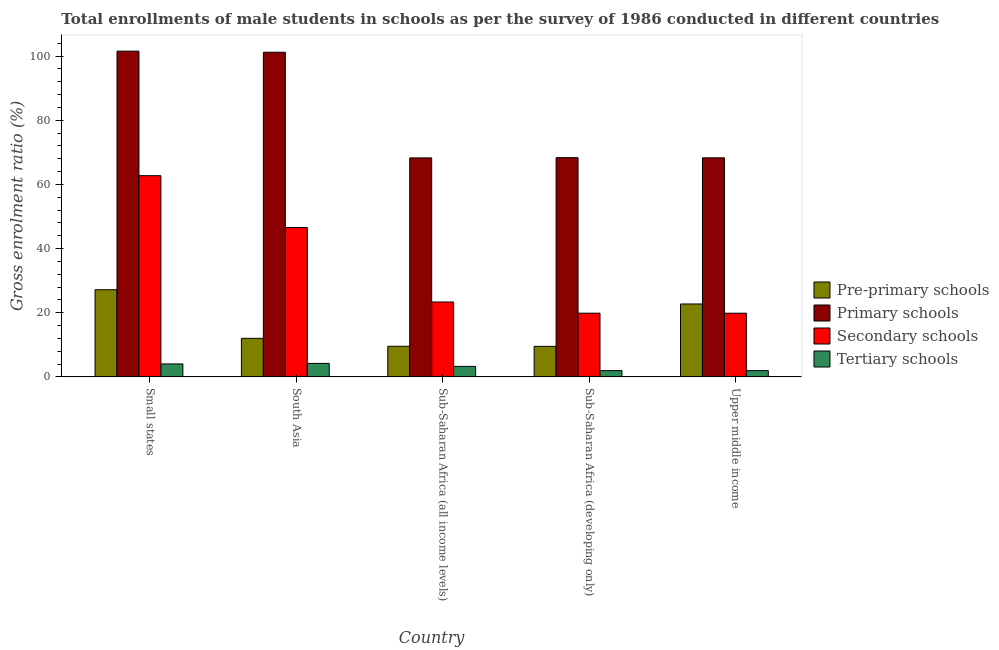Are the number of bars per tick equal to the number of legend labels?
Offer a terse response. Yes. Are the number of bars on each tick of the X-axis equal?
Your answer should be very brief. Yes. How many bars are there on the 4th tick from the left?
Keep it short and to the point. 4. How many bars are there on the 4th tick from the right?
Provide a succinct answer. 4. What is the label of the 5th group of bars from the left?
Offer a very short reply. Upper middle income. What is the gross enrolment ratio(male) in secondary schools in Sub-Saharan Africa (all income levels)?
Give a very brief answer. 23.34. Across all countries, what is the maximum gross enrolment ratio(male) in pre-primary schools?
Offer a very short reply. 27.16. Across all countries, what is the minimum gross enrolment ratio(male) in secondary schools?
Keep it short and to the point. 19.85. In which country was the gross enrolment ratio(male) in secondary schools maximum?
Your answer should be compact. Small states. In which country was the gross enrolment ratio(male) in primary schools minimum?
Offer a terse response. Sub-Saharan Africa (all income levels). What is the total gross enrolment ratio(male) in tertiary schools in the graph?
Provide a succinct answer. 15.39. What is the difference between the gross enrolment ratio(male) in tertiary schools in South Asia and that in Sub-Saharan Africa (developing only)?
Give a very brief answer. 2.24. What is the difference between the gross enrolment ratio(male) in primary schools in Sub-Saharan Africa (developing only) and the gross enrolment ratio(male) in tertiary schools in Upper middle income?
Offer a terse response. 66.39. What is the average gross enrolment ratio(male) in secondary schools per country?
Your response must be concise. 34.47. What is the difference between the gross enrolment ratio(male) in secondary schools and gross enrolment ratio(male) in tertiary schools in Upper middle income?
Ensure brevity in your answer.  17.9. In how many countries, is the gross enrolment ratio(male) in primary schools greater than 76 %?
Make the answer very short. 2. What is the ratio of the gross enrolment ratio(male) in primary schools in Sub-Saharan Africa (all income levels) to that in Sub-Saharan Africa (developing only)?
Keep it short and to the point. 1. Is the difference between the gross enrolment ratio(male) in tertiary schools in Sub-Saharan Africa (all income levels) and Sub-Saharan Africa (developing only) greater than the difference between the gross enrolment ratio(male) in primary schools in Sub-Saharan Africa (all income levels) and Sub-Saharan Africa (developing only)?
Ensure brevity in your answer.  Yes. What is the difference between the highest and the second highest gross enrolment ratio(male) in tertiary schools?
Make the answer very short. 0.16. What is the difference between the highest and the lowest gross enrolment ratio(male) in secondary schools?
Offer a terse response. 42.88. In how many countries, is the gross enrolment ratio(male) in tertiary schools greater than the average gross enrolment ratio(male) in tertiary schools taken over all countries?
Make the answer very short. 3. Is the sum of the gross enrolment ratio(male) in primary schools in South Asia and Sub-Saharan Africa (developing only) greater than the maximum gross enrolment ratio(male) in tertiary schools across all countries?
Provide a short and direct response. Yes. Is it the case that in every country, the sum of the gross enrolment ratio(male) in tertiary schools and gross enrolment ratio(male) in secondary schools is greater than the sum of gross enrolment ratio(male) in pre-primary schools and gross enrolment ratio(male) in primary schools?
Your answer should be very brief. No. What does the 4th bar from the left in Sub-Saharan Africa (all income levels) represents?
Give a very brief answer. Tertiary schools. What does the 3rd bar from the right in Upper middle income represents?
Give a very brief answer. Primary schools. Is it the case that in every country, the sum of the gross enrolment ratio(male) in pre-primary schools and gross enrolment ratio(male) in primary schools is greater than the gross enrolment ratio(male) in secondary schools?
Offer a very short reply. Yes. Are all the bars in the graph horizontal?
Offer a terse response. No. What is the difference between two consecutive major ticks on the Y-axis?
Your answer should be very brief. 20. Where does the legend appear in the graph?
Give a very brief answer. Center right. How many legend labels are there?
Ensure brevity in your answer.  4. How are the legend labels stacked?
Your answer should be very brief. Vertical. What is the title of the graph?
Your answer should be very brief. Total enrollments of male students in schools as per the survey of 1986 conducted in different countries. What is the label or title of the X-axis?
Give a very brief answer. Country. What is the Gross enrolment ratio (%) of Pre-primary schools in Small states?
Your answer should be compact. 27.16. What is the Gross enrolment ratio (%) in Primary schools in Small states?
Give a very brief answer. 101.54. What is the Gross enrolment ratio (%) in Secondary schools in Small states?
Ensure brevity in your answer.  62.72. What is the Gross enrolment ratio (%) in Tertiary schools in Small states?
Make the answer very short. 4.03. What is the Gross enrolment ratio (%) in Pre-primary schools in South Asia?
Give a very brief answer. 12.02. What is the Gross enrolment ratio (%) of Primary schools in South Asia?
Offer a very short reply. 101.2. What is the Gross enrolment ratio (%) in Secondary schools in South Asia?
Your answer should be very brief. 46.57. What is the Gross enrolment ratio (%) in Tertiary schools in South Asia?
Offer a terse response. 4.19. What is the Gross enrolment ratio (%) of Pre-primary schools in Sub-Saharan Africa (all income levels)?
Offer a very short reply. 9.53. What is the Gross enrolment ratio (%) of Primary schools in Sub-Saharan Africa (all income levels)?
Your answer should be compact. 68.27. What is the Gross enrolment ratio (%) in Secondary schools in Sub-Saharan Africa (all income levels)?
Provide a succinct answer. 23.34. What is the Gross enrolment ratio (%) in Tertiary schools in Sub-Saharan Africa (all income levels)?
Your answer should be very brief. 3.26. What is the Gross enrolment ratio (%) of Pre-primary schools in Sub-Saharan Africa (developing only)?
Offer a very short reply. 9.52. What is the Gross enrolment ratio (%) of Primary schools in Sub-Saharan Africa (developing only)?
Your response must be concise. 68.34. What is the Gross enrolment ratio (%) of Secondary schools in Sub-Saharan Africa (developing only)?
Give a very brief answer. 19.85. What is the Gross enrolment ratio (%) in Tertiary schools in Sub-Saharan Africa (developing only)?
Offer a very short reply. 1.95. What is the Gross enrolment ratio (%) in Pre-primary schools in Upper middle income?
Offer a very short reply. 22.73. What is the Gross enrolment ratio (%) of Primary schools in Upper middle income?
Provide a succinct answer. 68.29. What is the Gross enrolment ratio (%) of Secondary schools in Upper middle income?
Your answer should be very brief. 19.85. What is the Gross enrolment ratio (%) of Tertiary schools in Upper middle income?
Provide a succinct answer. 1.95. Across all countries, what is the maximum Gross enrolment ratio (%) in Pre-primary schools?
Your answer should be very brief. 27.16. Across all countries, what is the maximum Gross enrolment ratio (%) in Primary schools?
Ensure brevity in your answer.  101.54. Across all countries, what is the maximum Gross enrolment ratio (%) in Secondary schools?
Provide a succinct answer. 62.72. Across all countries, what is the maximum Gross enrolment ratio (%) in Tertiary schools?
Your answer should be very brief. 4.19. Across all countries, what is the minimum Gross enrolment ratio (%) of Pre-primary schools?
Your answer should be very brief. 9.52. Across all countries, what is the minimum Gross enrolment ratio (%) in Primary schools?
Your response must be concise. 68.27. Across all countries, what is the minimum Gross enrolment ratio (%) of Secondary schools?
Make the answer very short. 19.85. Across all countries, what is the minimum Gross enrolment ratio (%) in Tertiary schools?
Make the answer very short. 1.95. What is the total Gross enrolment ratio (%) of Pre-primary schools in the graph?
Ensure brevity in your answer.  80.96. What is the total Gross enrolment ratio (%) in Primary schools in the graph?
Ensure brevity in your answer.  407.63. What is the total Gross enrolment ratio (%) of Secondary schools in the graph?
Offer a very short reply. 172.34. What is the total Gross enrolment ratio (%) of Tertiary schools in the graph?
Ensure brevity in your answer.  15.39. What is the difference between the Gross enrolment ratio (%) of Pre-primary schools in Small states and that in South Asia?
Your answer should be very brief. 15.14. What is the difference between the Gross enrolment ratio (%) of Primary schools in Small states and that in South Asia?
Your answer should be very brief. 0.34. What is the difference between the Gross enrolment ratio (%) in Secondary schools in Small states and that in South Asia?
Offer a terse response. 16.15. What is the difference between the Gross enrolment ratio (%) in Tertiary schools in Small states and that in South Asia?
Provide a short and direct response. -0.16. What is the difference between the Gross enrolment ratio (%) in Pre-primary schools in Small states and that in Sub-Saharan Africa (all income levels)?
Give a very brief answer. 17.63. What is the difference between the Gross enrolment ratio (%) of Primary schools in Small states and that in Sub-Saharan Africa (all income levels)?
Your response must be concise. 33.28. What is the difference between the Gross enrolment ratio (%) of Secondary schools in Small states and that in Sub-Saharan Africa (all income levels)?
Offer a very short reply. 39.38. What is the difference between the Gross enrolment ratio (%) in Tertiary schools in Small states and that in Sub-Saharan Africa (all income levels)?
Give a very brief answer. 0.77. What is the difference between the Gross enrolment ratio (%) of Pre-primary schools in Small states and that in Sub-Saharan Africa (developing only)?
Your response must be concise. 17.64. What is the difference between the Gross enrolment ratio (%) of Primary schools in Small states and that in Sub-Saharan Africa (developing only)?
Your answer should be compact. 33.2. What is the difference between the Gross enrolment ratio (%) in Secondary schools in Small states and that in Sub-Saharan Africa (developing only)?
Offer a very short reply. 42.87. What is the difference between the Gross enrolment ratio (%) of Tertiary schools in Small states and that in Sub-Saharan Africa (developing only)?
Your response must be concise. 2.08. What is the difference between the Gross enrolment ratio (%) of Pre-primary schools in Small states and that in Upper middle income?
Your answer should be compact. 4.43. What is the difference between the Gross enrolment ratio (%) in Primary schools in Small states and that in Upper middle income?
Provide a short and direct response. 33.25. What is the difference between the Gross enrolment ratio (%) of Secondary schools in Small states and that in Upper middle income?
Provide a short and direct response. 42.88. What is the difference between the Gross enrolment ratio (%) in Tertiary schools in Small states and that in Upper middle income?
Provide a short and direct response. 2.08. What is the difference between the Gross enrolment ratio (%) of Pre-primary schools in South Asia and that in Sub-Saharan Africa (all income levels)?
Offer a very short reply. 2.48. What is the difference between the Gross enrolment ratio (%) in Primary schools in South Asia and that in Sub-Saharan Africa (all income levels)?
Give a very brief answer. 32.93. What is the difference between the Gross enrolment ratio (%) of Secondary schools in South Asia and that in Sub-Saharan Africa (all income levels)?
Offer a terse response. 23.22. What is the difference between the Gross enrolment ratio (%) of Tertiary schools in South Asia and that in Sub-Saharan Africa (all income levels)?
Make the answer very short. 0.94. What is the difference between the Gross enrolment ratio (%) of Pre-primary schools in South Asia and that in Sub-Saharan Africa (developing only)?
Your response must be concise. 2.5. What is the difference between the Gross enrolment ratio (%) of Primary schools in South Asia and that in Sub-Saharan Africa (developing only)?
Offer a very short reply. 32.86. What is the difference between the Gross enrolment ratio (%) in Secondary schools in South Asia and that in Sub-Saharan Africa (developing only)?
Offer a very short reply. 26.72. What is the difference between the Gross enrolment ratio (%) of Tertiary schools in South Asia and that in Sub-Saharan Africa (developing only)?
Give a very brief answer. 2.24. What is the difference between the Gross enrolment ratio (%) in Pre-primary schools in South Asia and that in Upper middle income?
Ensure brevity in your answer.  -10.71. What is the difference between the Gross enrolment ratio (%) of Primary schools in South Asia and that in Upper middle income?
Give a very brief answer. 32.91. What is the difference between the Gross enrolment ratio (%) of Secondary schools in South Asia and that in Upper middle income?
Provide a short and direct response. 26.72. What is the difference between the Gross enrolment ratio (%) in Tertiary schools in South Asia and that in Upper middle income?
Give a very brief answer. 2.24. What is the difference between the Gross enrolment ratio (%) in Pre-primary schools in Sub-Saharan Africa (all income levels) and that in Sub-Saharan Africa (developing only)?
Give a very brief answer. 0.02. What is the difference between the Gross enrolment ratio (%) in Primary schools in Sub-Saharan Africa (all income levels) and that in Sub-Saharan Africa (developing only)?
Offer a terse response. -0.07. What is the difference between the Gross enrolment ratio (%) of Secondary schools in Sub-Saharan Africa (all income levels) and that in Sub-Saharan Africa (developing only)?
Offer a terse response. 3.49. What is the difference between the Gross enrolment ratio (%) in Tertiary schools in Sub-Saharan Africa (all income levels) and that in Sub-Saharan Africa (developing only)?
Offer a very short reply. 1.31. What is the difference between the Gross enrolment ratio (%) of Pre-primary schools in Sub-Saharan Africa (all income levels) and that in Upper middle income?
Your answer should be very brief. -13.19. What is the difference between the Gross enrolment ratio (%) of Primary schools in Sub-Saharan Africa (all income levels) and that in Upper middle income?
Your answer should be compact. -0.02. What is the difference between the Gross enrolment ratio (%) of Secondary schools in Sub-Saharan Africa (all income levels) and that in Upper middle income?
Offer a terse response. 3.5. What is the difference between the Gross enrolment ratio (%) of Tertiary schools in Sub-Saharan Africa (all income levels) and that in Upper middle income?
Make the answer very short. 1.31. What is the difference between the Gross enrolment ratio (%) in Pre-primary schools in Sub-Saharan Africa (developing only) and that in Upper middle income?
Offer a terse response. -13.21. What is the difference between the Gross enrolment ratio (%) of Primary schools in Sub-Saharan Africa (developing only) and that in Upper middle income?
Make the answer very short. 0.05. What is the difference between the Gross enrolment ratio (%) in Secondary schools in Sub-Saharan Africa (developing only) and that in Upper middle income?
Your answer should be very brief. 0. What is the difference between the Gross enrolment ratio (%) of Tertiary schools in Sub-Saharan Africa (developing only) and that in Upper middle income?
Ensure brevity in your answer.  -0. What is the difference between the Gross enrolment ratio (%) of Pre-primary schools in Small states and the Gross enrolment ratio (%) of Primary schools in South Asia?
Offer a very short reply. -74.04. What is the difference between the Gross enrolment ratio (%) in Pre-primary schools in Small states and the Gross enrolment ratio (%) in Secondary schools in South Asia?
Your answer should be compact. -19.41. What is the difference between the Gross enrolment ratio (%) in Pre-primary schools in Small states and the Gross enrolment ratio (%) in Tertiary schools in South Asia?
Your answer should be very brief. 22.97. What is the difference between the Gross enrolment ratio (%) in Primary schools in Small states and the Gross enrolment ratio (%) in Secondary schools in South Asia?
Offer a terse response. 54.97. What is the difference between the Gross enrolment ratio (%) of Primary schools in Small states and the Gross enrolment ratio (%) of Tertiary schools in South Asia?
Make the answer very short. 97.35. What is the difference between the Gross enrolment ratio (%) of Secondary schools in Small states and the Gross enrolment ratio (%) of Tertiary schools in South Asia?
Keep it short and to the point. 58.53. What is the difference between the Gross enrolment ratio (%) in Pre-primary schools in Small states and the Gross enrolment ratio (%) in Primary schools in Sub-Saharan Africa (all income levels)?
Keep it short and to the point. -41.11. What is the difference between the Gross enrolment ratio (%) of Pre-primary schools in Small states and the Gross enrolment ratio (%) of Secondary schools in Sub-Saharan Africa (all income levels)?
Your answer should be very brief. 3.82. What is the difference between the Gross enrolment ratio (%) of Pre-primary schools in Small states and the Gross enrolment ratio (%) of Tertiary schools in Sub-Saharan Africa (all income levels)?
Provide a succinct answer. 23.9. What is the difference between the Gross enrolment ratio (%) of Primary schools in Small states and the Gross enrolment ratio (%) of Secondary schools in Sub-Saharan Africa (all income levels)?
Your answer should be very brief. 78.2. What is the difference between the Gross enrolment ratio (%) in Primary schools in Small states and the Gross enrolment ratio (%) in Tertiary schools in Sub-Saharan Africa (all income levels)?
Make the answer very short. 98.28. What is the difference between the Gross enrolment ratio (%) in Secondary schools in Small states and the Gross enrolment ratio (%) in Tertiary schools in Sub-Saharan Africa (all income levels)?
Ensure brevity in your answer.  59.46. What is the difference between the Gross enrolment ratio (%) of Pre-primary schools in Small states and the Gross enrolment ratio (%) of Primary schools in Sub-Saharan Africa (developing only)?
Keep it short and to the point. -41.18. What is the difference between the Gross enrolment ratio (%) of Pre-primary schools in Small states and the Gross enrolment ratio (%) of Secondary schools in Sub-Saharan Africa (developing only)?
Offer a terse response. 7.31. What is the difference between the Gross enrolment ratio (%) of Pre-primary schools in Small states and the Gross enrolment ratio (%) of Tertiary schools in Sub-Saharan Africa (developing only)?
Offer a very short reply. 25.21. What is the difference between the Gross enrolment ratio (%) of Primary schools in Small states and the Gross enrolment ratio (%) of Secondary schools in Sub-Saharan Africa (developing only)?
Ensure brevity in your answer.  81.69. What is the difference between the Gross enrolment ratio (%) in Primary schools in Small states and the Gross enrolment ratio (%) in Tertiary schools in Sub-Saharan Africa (developing only)?
Your answer should be very brief. 99.59. What is the difference between the Gross enrolment ratio (%) in Secondary schools in Small states and the Gross enrolment ratio (%) in Tertiary schools in Sub-Saharan Africa (developing only)?
Provide a short and direct response. 60.77. What is the difference between the Gross enrolment ratio (%) of Pre-primary schools in Small states and the Gross enrolment ratio (%) of Primary schools in Upper middle income?
Give a very brief answer. -41.13. What is the difference between the Gross enrolment ratio (%) in Pre-primary schools in Small states and the Gross enrolment ratio (%) in Secondary schools in Upper middle income?
Your answer should be very brief. 7.31. What is the difference between the Gross enrolment ratio (%) in Pre-primary schools in Small states and the Gross enrolment ratio (%) in Tertiary schools in Upper middle income?
Make the answer very short. 25.21. What is the difference between the Gross enrolment ratio (%) of Primary schools in Small states and the Gross enrolment ratio (%) of Secondary schools in Upper middle income?
Your answer should be compact. 81.69. What is the difference between the Gross enrolment ratio (%) in Primary schools in Small states and the Gross enrolment ratio (%) in Tertiary schools in Upper middle income?
Give a very brief answer. 99.59. What is the difference between the Gross enrolment ratio (%) in Secondary schools in Small states and the Gross enrolment ratio (%) in Tertiary schools in Upper middle income?
Your answer should be very brief. 60.77. What is the difference between the Gross enrolment ratio (%) of Pre-primary schools in South Asia and the Gross enrolment ratio (%) of Primary schools in Sub-Saharan Africa (all income levels)?
Make the answer very short. -56.25. What is the difference between the Gross enrolment ratio (%) in Pre-primary schools in South Asia and the Gross enrolment ratio (%) in Secondary schools in Sub-Saharan Africa (all income levels)?
Ensure brevity in your answer.  -11.33. What is the difference between the Gross enrolment ratio (%) in Pre-primary schools in South Asia and the Gross enrolment ratio (%) in Tertiary schools in Sub-Saharan Africa (all income levels)?
Ensure brevity in your answer.  8.76. What is the difference between the Gross enrolment ratio (%) in Primary schools in South Asia and the Gross enrolment ratio (%) in Secondary schools in Sub-Saharan Africa (all income levels)?
Provide a succinct answer. 77.85. What is the difference between the Gross enrolment ratio (%) in Primary schools in South Asia and the Gross enrolment ratio (%) in Tertiary schools in Sub-Saharan Africa (all income levels)?
Provide a short and direct response. 97.94. What is the difference between the Gross enrolment ratio (%) in Secondary schools in South Asia and the Gross enrolment ratio (%) in Tertiary schools in Sub-Saharan Africa (all income levels)?
Your answer should be very brief. 43.31. What is the difference between the Gross enrolment ratio (%) of Pre-primary schools in South Asia and the Gross enrolment ratio (%) of Primary schools in Sub-Saharan Africa (developing only)?
Provide a short and direct response. -56.32. What is the difference between the Gross enrolment ratio (%) of Pre-primary schools in South Asia and the Gross enrolment ratio (%) of Secondary schools in Sub-Saharan Africa (developing only)?
Provide a short and direct response. -7.83. What is the difference between the Gross enrolment ratio (%) of Pre-primary schools in South Asia and the Gross enrolment ratio (%) of Tertiary schools in Sub-Saharan Africa (developing only)?
Provide a succinct answer. 10.07. What is the difference between the Gross enrolment ratio (%) in Primary schools in South Asia and the Gross enrolment ratio (%) in Secondary schools in Sub-Saharan Africa (developing only)?
Your response must be concise. 81.35. What is the difference between the Gross enrolment ratio (%) of Primary schools in South Asia and the Gross enrolment ratio (%) of Tertiary schools in Sub-Saharan Africa (developing only)?
Your response must be concise. 99.25. What is the difference between the Gross enrolment ratio (%) of Secondary schools in South Asia and the Gross enrolment ratio (%) of Tertiary schools in Sub-Saharan Africa (developing only)?
Your answer should be very brief. 44.62. What is the difference between the Gross enrolment ratio (%) of Pre-primary schools in South Asia and the Gross enrolment ratio (%) of Primary schools in Upper middle income?
Your answer should be very brief. -56.27. What is the difference between the Gross enrolment ratio (%) in Pre-primary schools in South Asia and the Gross enrolment ratio (%) in Secondary schools in Upper middle income?
Provide a short and direct response. -7.83. What is the difference between the Gross enrolment ratio (%) of Pre-primary schools in South Asia and the Gross enrolment ratio (%) of Tertiary schools in Upper middle income?
Ensure brevity in your answer.  10.06. What is the difference between the Gross enrolment ratio (%) in Primary schools in South Asia and the Gross enrolment ratio (%) in Secondary schools in Upper middle income?
Make the answer very short. 81.35. What is the difference between the Gross enrolment ratio (%) in Primary schools in South Asia and the Gross enrolment ratio (%) in Tertiary schools in Upper middle income?
Your answer should be very brief. 99.25. What is the difference between the Gross enrolment ratio (%) of Secondary schools in South Asia and the Gross enrolment ratio (%) of Tertiary schools in Upper middle income?
Your answer should be very brief. 44.62. What is the difference between the Gross enrolment ratio (%) of Pre-primary schools in Sub-Saharan Africa (all income levels) and the Gross enrolment ratio (%) of Primary schools in Sub-Saharan Africa (developing only)?
Provide a succinct answer. -58.8. What is the difference between the Gross enrolment ratio (%) in Pre-primary schools in Sub-Saharan Africa (all income levels) and the Gross enrolment ratio (%) in Secondary schools in Sub-Saharan Africa (developing only)?
Provide a short and direct response. -10.32. What is the difference between the Gross enrolment ratio (%) of Pre-primary schools in Sub-Saharan Africa (all income levels) and the Gross enrolment ratio (%) of Tertiary schools in Sub-Saharan Africa (developing only)?
Keep it short and to the point. 7.58. What is the difference between the Gross enrolment ratio (%) in Primary schools in Sub-Saharan Africa (all income levels) and the Gross enrolment ratio (%) in Secondary schools in Sub-Saharan Africa (developing only)?
Keep it short and to the point. 48.42. What is the difference between the Gross enrolment ratio (%) of Primary schools in Sub-Saharan Africa (all income levels) and the Gross enrolment ratio (%) of Tertiary schools in Sub-Saharan Africa (developing only)?
Your answer should be compact. 66.32. What is the difference between the Gross enrolment ratio (%) of Secondary schools in Sub-Saharan Africa (all income levels) and the Gross enrolment ratio (%) of Tertiary schools in Sub-Saharan Africa (developing only)?
Make the answer very short. 21.39. What is the difference between the Gross enrolment ratio (%) of Pre-primary schools in Sub-Saharan Africa (all income levels) and the Gross enrolment ratio (%) of Primary schools in Upper middle income?
Keep it short and to the point. -58.76. What is the difference between the Gross enrolment ratio (%) in Pre-primary schools in Sub-Saharan Africa (all income levels) and the Gross enrolment ratio (%) in Secondary schools in Upper middle income?
Offer a very short reply. -10.31. What is the difference between the Gross enrolment ratio (%) of Pre-primary schools in Sub-Saharan Africa (all income levels) and the Gross enrolment ratio (%) of Tertiary schools in Upper middle income?
Give a very brief answer. 7.58. What is the difference between the Gross enrolment ratio (%) in Primary schools in Sub-Saharan Africa (all income levels) and the Gross enrolment ratio (%) in Secondary schools in Upper middle income?
Your response must be concise. 48.42. What is the difference between the Gross enrolment ratio (%) in Primary schools in Sub-Saharan Africa (all income levels) and the Gross enrolment ratio (%) in Tertiary schools in Upper middle income?
Your answer should be very brief. 66.31. What is the difference between the Gross enrolment ratio (%) of Secondary schools in Sub-Saharan Africa (all income levels) and the Gross enrolment ratio (%) of Tertiary schools in Upper middle income?
Give a very brief answer. 21.39. What is the difference between the Gross enrolment ratio (%) of Pre-primary schools in Sub-Saharan Africa (developing only) and the Gross enrolment ratio (%) of Primary schools in Upper middle income?
Your response must be concise. -58.77. What is the difference between the Gross enrolment ratio (%) of Pre-primary schools in Sub-Saharan Africa (developing only) and the Gross enrolment ratio (%) of Secondary schools in Upper middle income?
Make the answer very short. -10.33. What is the difference between the Gross enrolment ratio (%) in Pre-primary schools in Sub-Saharan Africa (developing only) and the Gross enrolment ratio (%) in Tertiary schools in Upper middle income?
Ensure brevity in your answer.  7.56. What is the difference between the Gross enrolment ratio (%) of Primary schools in Sub-Saharan Africa (developing only) and the Gross enrolment ratio (%) of Secondary schools in Upper middle income?
Make the answer very short. 48.49. What is the difference between the Gross enrolment ratio (%) in Primary schools in Sub-Saharan Africa (developing only) and the Gross enrolment ratio (%) in Tertiary schools in Upper middle income?
Your response must be concise. 66.39. What is the difference between the Gross enrolment ratio (%) of Secondary schools in Sub-Saharan Africa (developing only) and the Gross enrolment ratio (%) of Tertiary schools in Upper middle income?
Your response must be concise. 17.9. What is the average Gross enrolment ratio (%) in Pre-primary schools per country?
Keep it short and to the point. 16.19. What is the average Gross enrolment ratio (%) of Primary schools per country?
Provide a succinct answer. 81.53. What is the average Gross enrolment ratio (%) in Secondary schools per country?
Make the answer very short. 34.47. What is the average Gross enrolment ratio (%) in Tertiary schools per country?
Ensure brevity in your answer.  3.08. What is the difference between the Gross enrolment ratio (%) of Pre-primary schools and Gross enrolment ratio (%) of Primary schools in Small states?
Your answer should be compact. -74.38. What is the difference between the Gross enrolment ratio (%) in Pre-primary schools and Gross enrolment ratio (%) in Secondary schools in Small states?
Keep it short and to the point. -35.56. What is the difference between the Gross enrolment ratio (%) of Pre-primary schools and Gross enrolment ratio (%) of Tertiary schools in Small states?
Provide a succinct answer. 23.13. What is the difference between the Gross enrolment ratio (%) of Primary schools and Gross enrolment ratio (%) of Secondary schools in Small states?
Ensure brevity in your answer.  38.82. What is the difference between the Gross enrolment ratio (%) in Primary schools and Gross enrolment ratio (%) in Tertiary schools in Small states?
Ensure brevity in your answer.  97.51. What is the difference between the Gross enrolment ratio (%) in Secondary schools and Gross enrolment ratio (%) in Tertiary schools in Small states?
Make the answer very short. 58.69. What is the difference between the Gross enrolment ratio (%) in Pre-primary schools and Gross enrolment ratio (%) in Primary schools in South Asia?
Offer a terse response. -89.18. What is the difference between the Gross enrolment ratio (%) of Pre-primary schools and Gross enrolment ratio (%) of Secondary schools in South Asia?
Keep it short and to the point. -34.55. What is the difference between the Gross enrolment ratio (%) in Pre-primary schools and Gross enrolment ratio (%) in Tertiary schools in South Asia?
Offer a very short reply. 7.82. What is the difference between the Gross enrolment ratio (%) in Primary schools and Gross enrolment ratio (%) in Secondary schools in South Asia?
Your answer should be compact. 54.63. What is the difference between the Gross enrolment ratio (%) in Primary schools and Gross enrolment ratio (%) in Tertiary schools in South Asia?
Offer a terse response. 97. What is the difference between the Gross enrolment ratio (%) in Secondary schools and Gross enrolment ratio (%) in Tertiary schools in South Asia?
Provide a short and direct response. 42.37. What is the difference between the Gross enrolment ratio (%) in Pre-primary schools and Gross enrolment ratio (%) in Primary schools in Sub-Saharan Africa (all income levels)?
Your answer should be compact. -58.73. What is the difference between the Gross enrolment ratio (%) in Pre-primary schools and Gross enrolment ratio (%) in Secondary schools in Sub-Saharan Africa (all income levels)?
Offer a terse response. -13.81. What is the difference between the Gross enrolment ratio (%) of Pre-primary schools and Gross enrolment ratio (%) of Tertiary schools in Sub-Saharan Africa (all income levels)?
Offer a very short reply. 6.28. What is the difference between the Gross enrolment ratio (%) in Primary schools and Gross enrolment ratio (%) in Secondary schools in Sub-Saharan Africa (all income levels)?
Keep it short and to the point. 44.92. What is the difference between the Gross enrolment ratio (%) of Primary schools and Gross enrolment ratio (%) of Tertiary schools in Sub-Saharan Africa (all income levels)?
Your answer should be very brief. 65.01. What is the difference between the Gross enrolment ratio (%) of Secondary schools and Gross enrolment ratio (%) of Tertiary schools in Sub-Saharan Africa (all income levels)?
Provide a short and direct response. 20.09. What is the difference between the Gross enrolment ratio (%) of Pre-primary schools and Gross enrolment ratio (%) of Primary schools in Sub-Saharan Africa (developing only)?
Offer a very short reply. -58.82. What is the difference between the Gross enrolment ratio (%) in Pre-primary schools and Gross enrolment ratio (%) in Secondary schools in Sub-Saharan Africa (developing only)?
Provide a succinct answer. -10.33. What is the difference between the Gross enrolment ratio (%) in Pre-primary schools and Gross enrolment ratio (%) in Tertiary schools in Sub-Saharan Africa (developing only)?
Ensure brevity in your answer.  7.57. What is the difference between the Gross enrolment ratio (%) in Primary schools and Gross enrolment ratio (%) in Secondary schools in Sub-Saharan Africa (developing only)?
Give a very brief answer. 48.49. What is the difference between the Gross enrolment ratio (%) in Primary schools and Gross enrolment ratio (%) in Tertiary schools in Sub-Saharan Africa (developing only)?
Provide a short and direct response. 66.39. What is the difference between the Gross enrolment ratio (%) in Secondary schools and Gross enrolment ratio (%) in Tertiary schools in Sub-Saharan Africa (developing only)?
Ensure brevity in your answer.  17.9. What is the difference between the Gross enrolment ratio (%) in Pre-primary schools and Gross enrolment ratio (%) in Primary schools in Upper middle income?
Provide a succinct answer. -45.56. What is the difference between the Gross enrolment ratio (%) of Pre-primary schools and Gross enrolment ratio (%) of Secondary schools in Upper middle income?
Offer a very short reply. 2.88. What is the difference between the Gross enrolment ratio (%) in Pre-primary schools and Gross enrolment ratio (%) in Tertiary schools in Upper middle income?
Give a very brief answer. 20.78. What is the difference between the Gross enrolment ratio (%) of Primary schools and Gross enrolment ratio (%) of Secondary schools in Upper middle income?
Your response must be concise. 48.44. What is the difference between the Gross enrolment ratio (%) in Primary schools and Gross enrolment ratio (%) in Tertiary schools in Upper middle income?
Keep it short and to the point. 66.34. What is the difference between the Gross enrolment ratio (%) in Secondary schools and Gross enrolment ratio (%) in Tertiary schools in Upper middle income?
Make the answer very short. 17.9. What is the ratio of the Gross enrolment ratio (%) in Pre-primary schools in Small states to that in South Asia?
Keep it short and to the point. 2.26. What is the ratio of the Gross enrolment ratio (%) in Secondary schools in Small states to that in South Asia?
Provide a succinct answer. 1.35. What is the ratio of the Gross enrolment ratio (%) of Tertiary schools in Small states to that in South Asia?
Keep it short and to the point. 0.96. What is the ratio of the Gross enrolment ratio (%) in Pre-primary schools in Small states to that in Sub-Saharan Africa (all income levels)?
Offer a very short reply. 2.85. What is the ratio of the Gross enrolment ratio (%) in Primary schools in Small states to that in Sub-Saharan Africa (all income levels)?
Give a very brief answer. 1.49. What is the ratio of the Gross enrolment ratio (%) of Secondary schools in Small states to that in Sub-Saharan Africa (all income levels)?
Provide a succinct answer. 2.69. What is the ratio of the Gross enrolment ratio (%) of Tertiary schools in Small states to that in Sub-Saharan Africa (all income levels)?
Give a very brief answer. 1.24. What is the ratio of the Gross enrolment ratio (%) of Pre-primary schools in Small states to that in Sub-Saharan Africa (developing only)?
Keep it short and to the point. 2.85. What is the ratio of the Gross enrolment ratio (%) in Primary schools in Small states to that in Sub-Saharan Africa (developing only)?
Your response must be concise. 1.49. What is the ratio of the Gross enrolment ratio (%) of Secondary schools in Small states to that in Sub-Saharan Africa (developing only)?
Your answer should be very brief. 3.16. What is the ratio of the Gross enrolment ratio (%) of Tertiary schools in Small states to that in Sub-Saharan Africa (developing only)?
Give a very brief answer. 2.07. What is the ratio of the Gross enrolment ratio (%) in Pre-primary schools in Small states to that in Upper middle income?
Provide a short and direct response. 1.2. What is the ratio of the Gross enrolment ratio (%) of Primary schools in Small states to that in Upper middle income?
Your answer should be very brief. 1.49. What is the ratio of the Gross enrolment ratio (%) in Secondary schools in Small states to that in Upper middle income?
Provide a short and direct response. 3.16. What is the ratio of the Gross enrolment ratio (%) of Tertiary schools in Small states to that in Upper middle income?
Your response must be concise. 2.07. What is the ratio of the Gross enrolment ratio (%) of Pre-primary schools in South Asia to that in Sub-Saharan Africa (all income levels)?
Make the answer very short. 1.26. What is the ratio of the Gross enrolment ratio (%) of Primary schools in South Asia to that in Sub-Saharan Africa (all income levels)?
Give a very brief answer. 1.48. What is the ratio of the Gross enrolment ratio (%) in Secondary schools in South Asia to that in Sub-Saharan Africa (all income levels)?
Ensure brevity in your answer.  1.99. What is the ratio of the Gross enrolment ratio (%) of Tertiary schools in South Asia to that in Sub-Saharan Africa (all income levels)?
Provide a succinct answer. 1.29. What is the ratio of the Gross enrolment ratio (%) in Pre-primary schools in South Asia to that in Sub-Saharan Africa (developing only)?
Your answer should be compact. 1.26. What is the ratio of the Gross enrolment ratio (%) of Primary schools in South Asia to that in Sub-Saharan Africa (developing only)?
Your answer should be very brief. 1.48. What is the ratio of the Gross enrolment ratio (%) of Secondary schools in South Asia to that in Sub-Saharan Africa (developing only)?
Offer a very short reply. 2.35. What is the ratio of the Gross enrolment ratio (%) of Tertiary schools in South Asia to that in Sub-Saharan Africa (developing only)?
Offer a very short reply. 2.15. What is the ratio of the Gross enrolment ratio (%) of Pre-primary schools in South Asia to that in Upper middle income?
Give a very brief answer. 0.53. What is the ratio of the Gross enrolment ratio (%) of Primary schools in South Asia to that in Upper middle income?
Make the answer very short. 1.48. What is the ratio of the Gross enrolment ratio (%) of Secondary schools in South Asia to that in Upper middle income?
Offer a very short reply. 2.35. What is the ratio of the Gross enrolment ratio (%) of Tertiary schools in South Asia to that in Upper middle income?
Offer a terse response. 2.15. What is the ratio of the Gross enrolment ratio (%) of Primary schools in Sub-Saharan Africa (all income levels) to that in Sub-Saharan Africa (developing only)?
Keep it short and to the point. 1. What is the ratio of the Gross enrolment ratio (%) of Secondary schools in Sub-Saharan Africa (all income levels) to that in Sub-Saharan Africa (developing only)?
Offer a very short reply. 1.18. What is the ratio of the Gross enrolment ratio (%) in Tertiary schools in Sub-Saharan Africa (all income levels) to that in Sub-Saharan Africa (developing only)?
Provide a short and direct response. 1.67. What is the ratio of the Gross enrolment ratio (%) of Pre-primary schools in Sub-Saharan Africa (all income levels) to that in Upper middle income?
Give a very brief answer. 0.42. What is the ratio of the Gross enrolment ratio (%) in Secondary schools in Sub-Saharan Africa (all income levels) to that in Upper middle income?
Provide a succinct answer. 1.18. What is the ratio of the Gross enrolment ratio (%) of Tertiary schools in Sub-Saharan Africa (all income levels) to that in Upper middle income?
Keep it short and to the point. 1.67. What is the ratio of the Gross enrolment ratio (%) of Pre-primary schools in Sub-Saharan Africa (developing only) to that in Upper middle income?
Provide a short and direct response. 0.42. What is the ratio of the Gross enrolment ratio (%) in Tertiary schools in Sub-Saharan Africa (developing only) to that in Upper middle income?
Offer a terse response. 1. What is the difference between the highest and the second highest Gross enrolment ratio (%) of Pre-primary schools?
Offer a terse response. 4.43. What is the difference between the highest and the second highest Gross enrolment ratio (%) in Primary schools?
Provide a short and direct response. 0.34. What is the difference between the highest and the second highest Gross enrolment ratio (%) in Secondary schools?
Offer a very short reply. 16.15. What is the difference between the highest and the second highest Gross enrolment ratio (%) of Tertiary schools?
Your response must be concise. 0.16. What is the difference between the highest and the lowest Gross enrolment ratio (%) in Pre-primary schools?
Offer a terse response. 17.64. What is the difference between the highest and the lowest Gross enrolment ratio (%) in Primary schools?
Provide a succinct answer. 33.28. What is the difference between the highest and the lowest Gross enrolment ratio (%) in Secondary schools?
Offer a very short reply. 42.88. What is the difference between the highest and the lowest Gross enrolment ratio (%) of Tertiary schools?
Make the answer very short. 2.24. 